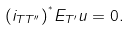<formula> <loc_0><loc_0><loc_500><loc_500>( i _ { T T ^ { \prime \prime } } ) ^ { ^ { * } } E _ { T ^ { \prime } } u = 0 .</formula> 